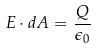<formula> <loc_0><loc_0><loc_500><loc_500>E \cdot d A = \frac { Q } { \epsilon _ { 0 } }</formula> 